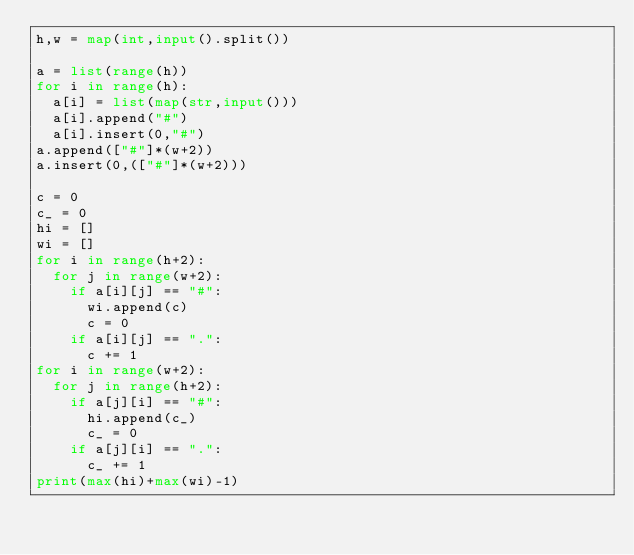Convert code to text. <code><loc_0><loc_0><loc_500><loc_500><_Python_>h,w = map(int,input().split())

a = list(range(h))
for i in range(h):
  a[i] = list(map(str,input()))
  a[i].append("#")
  a[i].insert(0,"#")
a.append(["#"]*(w+2))
a.insert(0,(["#"]*(w+2)))

c = 0
c_ = 0
hi = []
wi = []
for i in range(h+2):
  for j in range(w+2):
    if a[i][j] == "#":
      wi.append(c)
      c = 0
    if a[i][j] == ".":
      c += 1
for i in range(w+2):
  for j in range(h+2):    
    if a[j][i] == "#":
      hi.append(c_)
      c_ = 0
    if a[j][i] == ".":
      c_ += 1
print(max(hi)+max(wi)-1)
</code> 